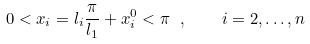<formula> <loc_0><loc_0><loc_500><loc_500>0 < x _ { i } = l _ { i } \frac { \pi } { l _ { 1 } } + x _ { i } ^ { 0 } < \pi \ , \quad i = 2 , \dots , n</formula> 